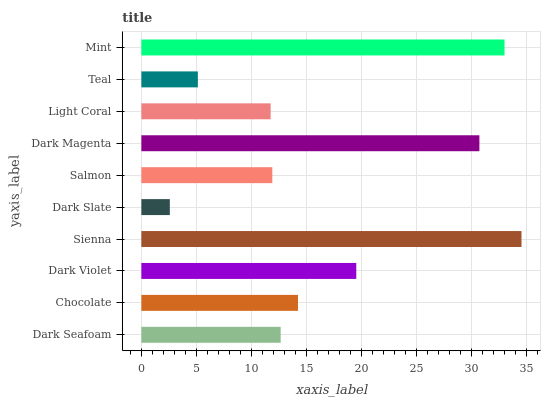Is Dark Slate the minimum?
Answer yes or no. Yes. Is Sienna the maximum?
Answer yes or no. Yes. Is Chocolate the minimum?
Answer yes or no. No. Is Chocolate the maximum?
Answer yes or no. No. Is Chocolate greater than Dark Seafoam?
Answer yes or no. Yes. Is Dark Seafoam less than Chocolate?
Answer yes or no. Yes. Is Dark Seafoam greater than Chocolate?
Answer yes or no. No. Is Chocolate less than Dark Seafoam?
Answer yes or no. No. Is Chocolate the high median?
Answer yes or no. Yes. Is Dark Seafoam the low median?
Answer yes or no. Yes. Is Salmon the high median?
Answer yes or no. No. Is Mint the low median?
Answer yes or no. No. 